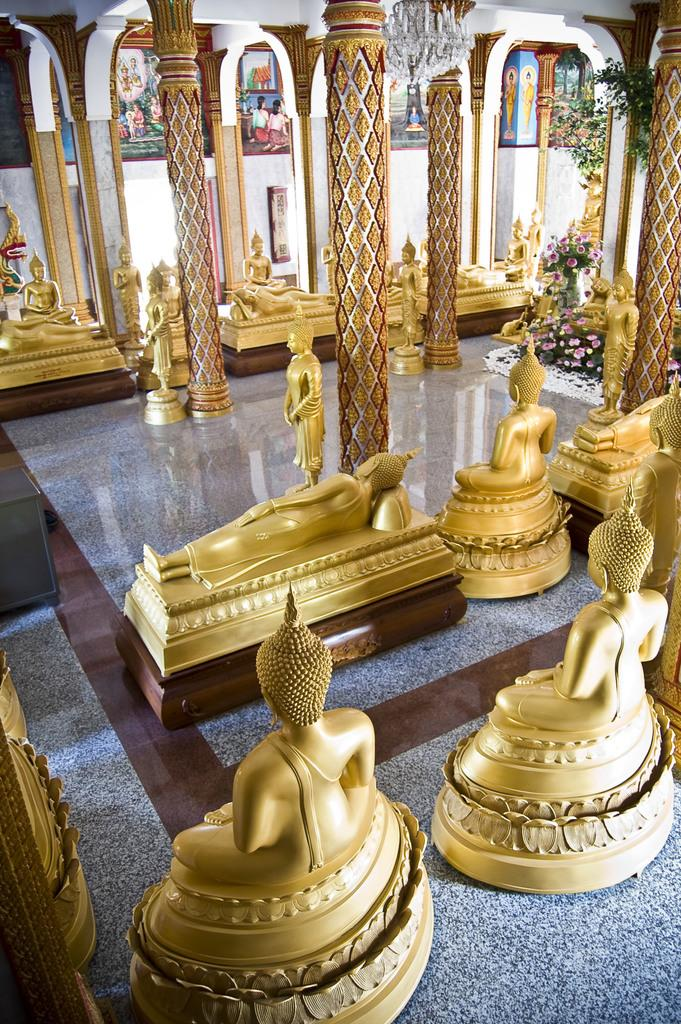What are the mini statues placed on in the image? The mini statues are placed on a granite surface in the image. What else can be seen in the image besides the mini statues? There are poles, plants, and a wall with frames in the image. How many credits are visible on the wall in the image? There is no mention of credits in the image; the wall has frames, but no credits are visible. 